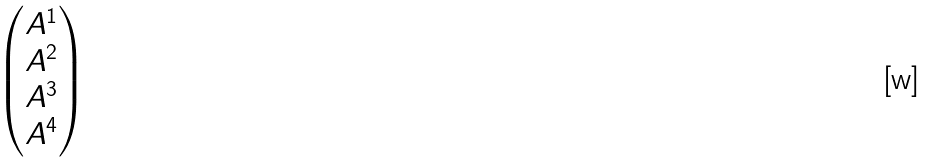Convert formula to latex. <formula><loc_0><loc_0><loc_500><loc_500>\begin{pmatrix} A ^ { 1 } \\ A ^ { 2 } \\ A ^ { 3 } \\ A ^ { 4 } \end{pmatrix}</formula> 